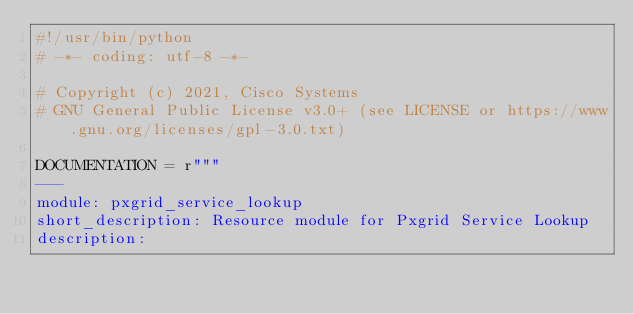Convert code to text. <code><loc_0><loc_0><loc_500><loc_500><_Python_>#!/usr/bin/python
# -*- coding: utf-8 -*-

# Copyright (c) 2021, Cisco Systems
# GNU General Public License v3.0+ (see LICENSE or https://www.gnu.org/licenses/gpl-3.0.txt)

DOCUMENTATION = r"""
---
module: pxgrid_service_lookup
short_description: Resource module for Pxgrid Service Lookup
description:</code> 